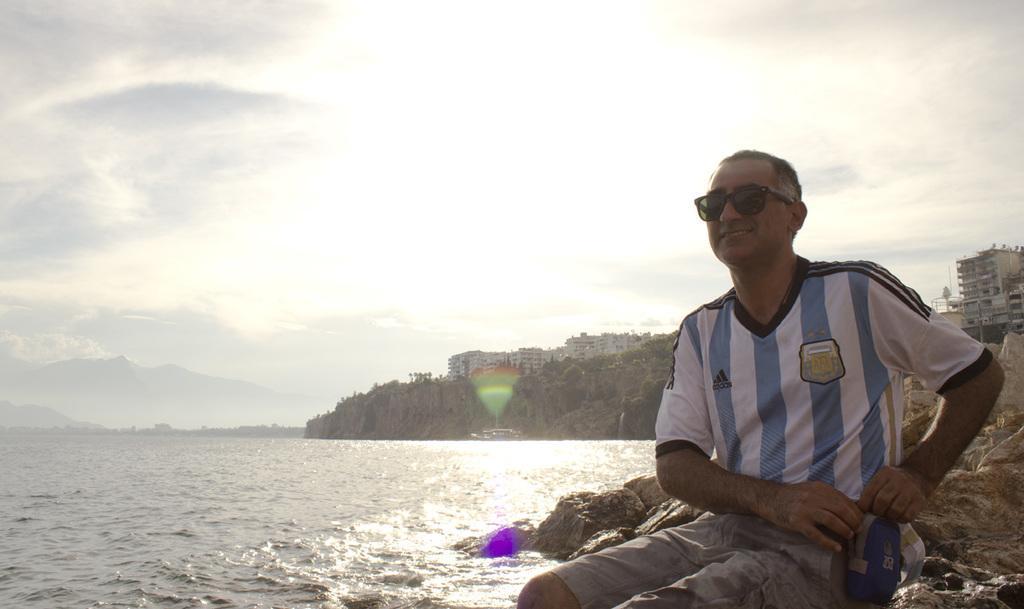How would you summarize this image in a sentence or two? Here we can see a man. He has goggles and he is smiling. This is water. In the background we can see buildings, rocks, and trees. This is sky with clouds. 